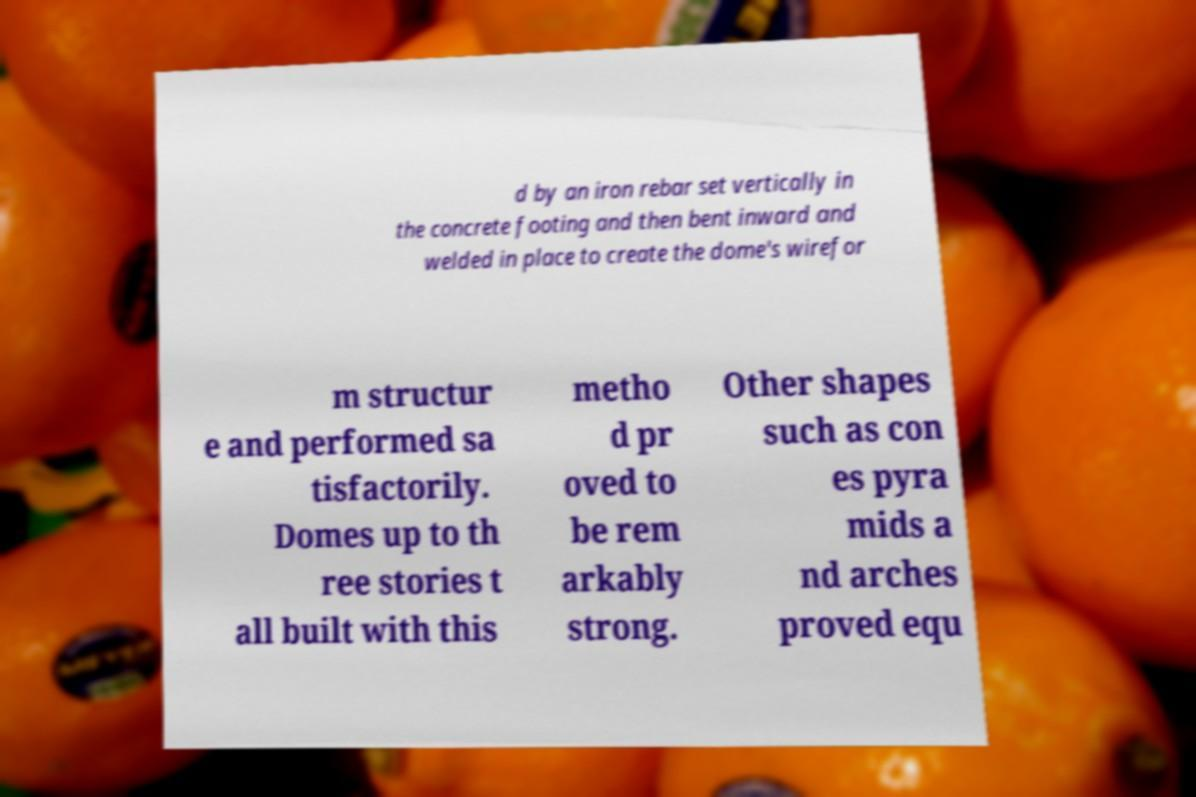Could you extract and type out the text from this image? d by an iron rebar set vertically in the concrete footing and then bent inward and welded in place to create the dome's wirefor m structur e and performed sa tisfactorily. Domes up to th ree stories t all built with this metho d pr oved to be rem arkably strong. Other shapes such as con es pyra mids a nd arches proved equ 